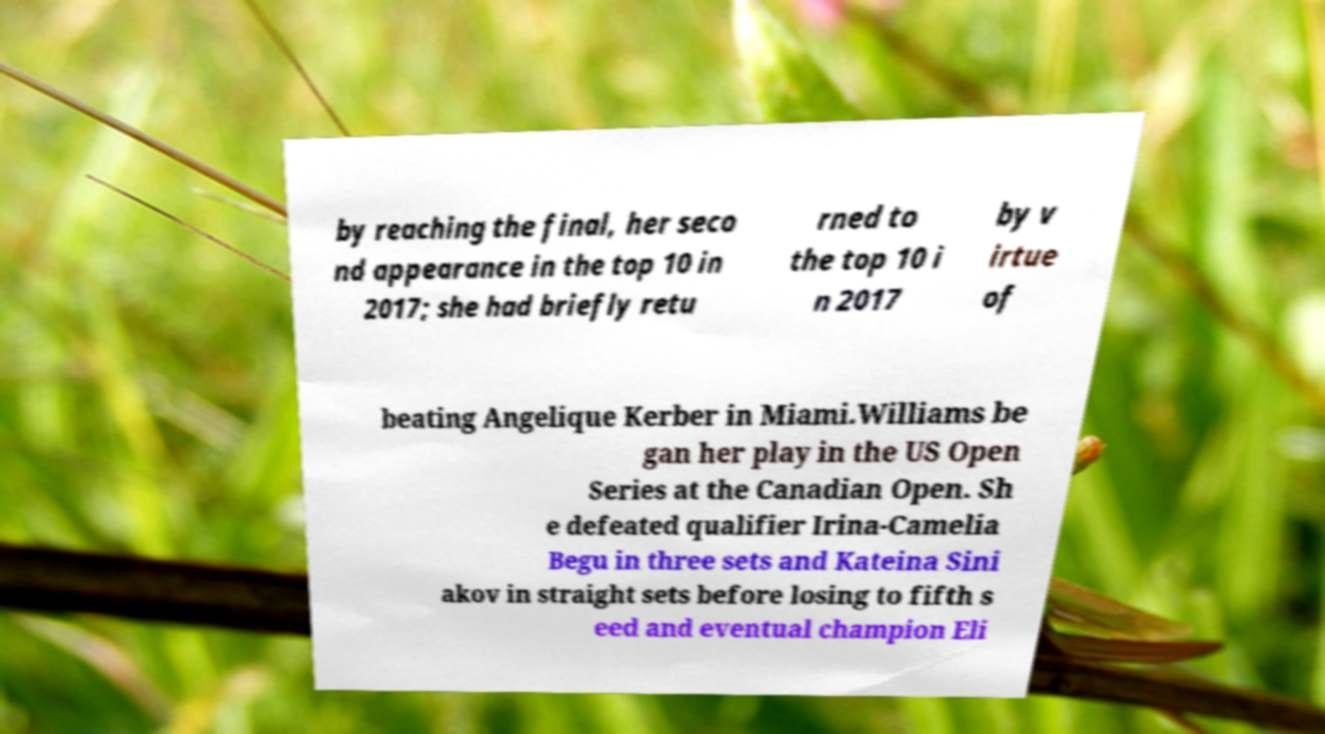I need the written content from this picture converted into text. Can you do that? by reaching the final, her seco nd appearance in the top 10 in 2017; she had briefly retu rned to the top 10 i n 2017 by v irtue of beating Angelique Kerber in Miami.Williams be gan her play in the US Open Series at the Canadian Open. Sh e defeated qualifier Irina-Camelia Begu in three sets and Kateina Sini akov in straight sets before losing to fifth s eed and eventual champion Eli 